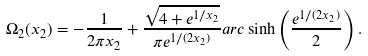Convert formula to latex. <formula><loc_0><loc_0><loc_500><loc_500>\Omega _ { 2 } ( x _ { 2 } ) = - \frac { 1 } { 2 \pi x _ { 2 } } + \frac { \sqrt { 4 + e ^ { 1 / x _ { 2 } } } } { \pi e ^ { 1 / ( 2 x _ { 2 } ) } } a r c \sinh \left ( \frac { e ^ { 1 / ( 2 x _ { 2 } ) } } { 2 } \right ) .</formula> 